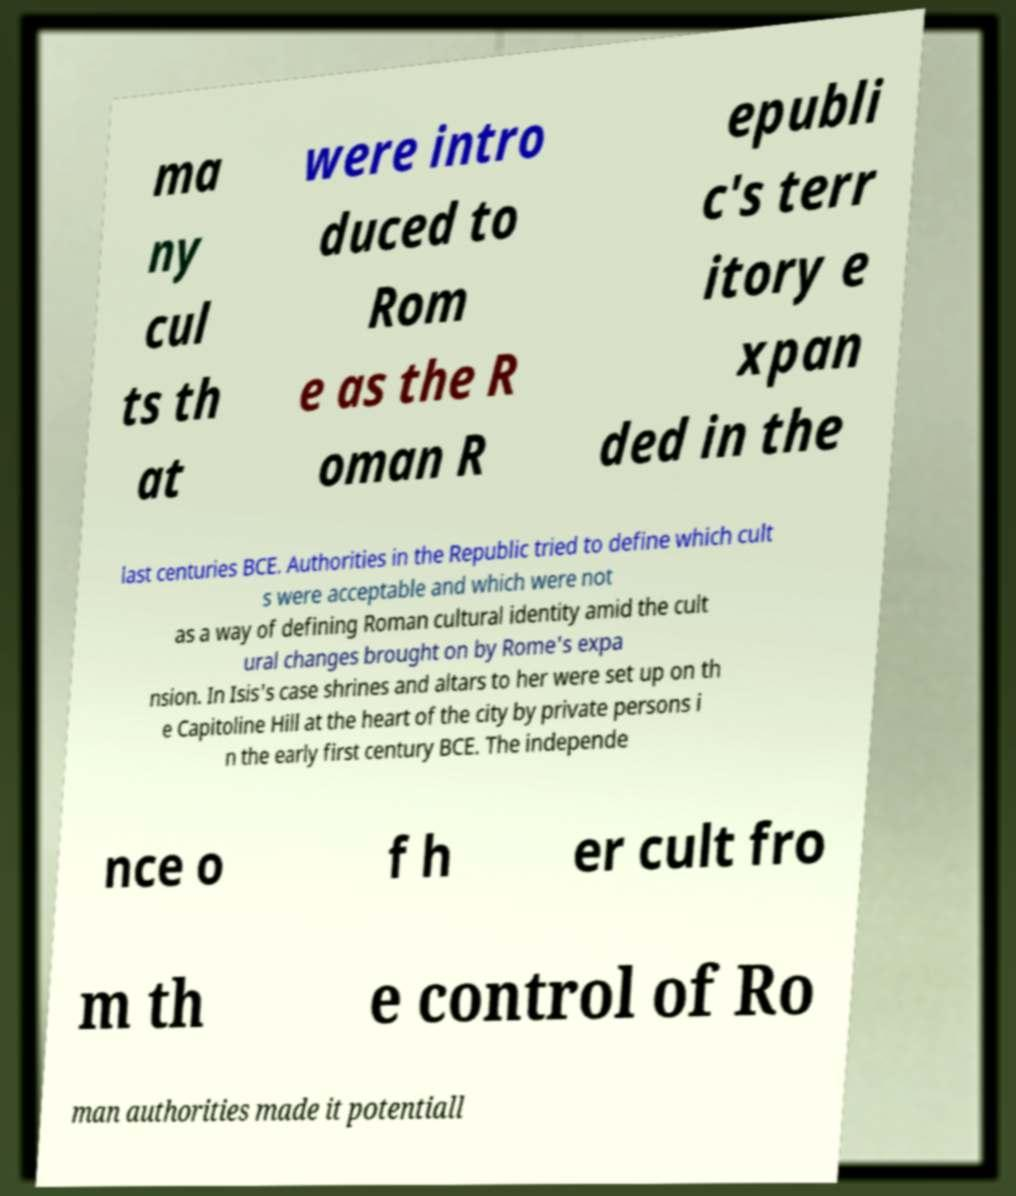I need the written content from this picture converted into text. Can you do that? ma ny cul ts th at were intro duced to Rom e as the R oman R epubli c's terr itory e xpan ded in the last centuries BCE. Authorities in the Republic tried to define which cult s were acceptable and which were not as a way of defining Roman cultural identity amid the cult ural changes brought on by Rome's expa nsion. In Isis's case shrines and altars to her were set up on th e Capitoline Hill at the heart of the city by private persons i n the early first century BCE. The independe nce o f h er cult fro m th e control of Ro man authorities made it potentiall 